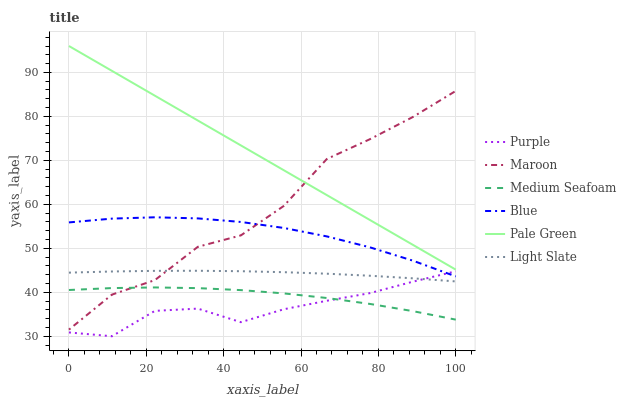Does Purple have the minimum area under the curve?
Answer yes or no. Yes. Does Pale Green have the maximum area under the curve?
Answer yes or no. Yes. Does Maroon have the minimum area under the curve?
Answer yes or no. No. Does Maroon have the maximum area under the curve?
Answer yes or no. No. Is Pale Green the smoothest?
Answer yes or no. Yes. Is Maroon the roughest?
Answer yes or no. Yes. Is Purple the smoothest?
Answer yes or no. No. Is Purple the roughest?
Answer yes or no. No. Does Maroon have the lowest value?
Answer yes or no. No. Does Pale Green have the highest value?
Answer yes or no. Yes. Does Purple have the highest value?
Answer yes or no. No. Is Medium Seafoam less than Light Slate?
Answer yes or no. Yes. Is Maroon greater than Purple?
Answer yes or no. Yes. Does Medium Seafoam intersect Light Slate?
Answer yes or no. No. 